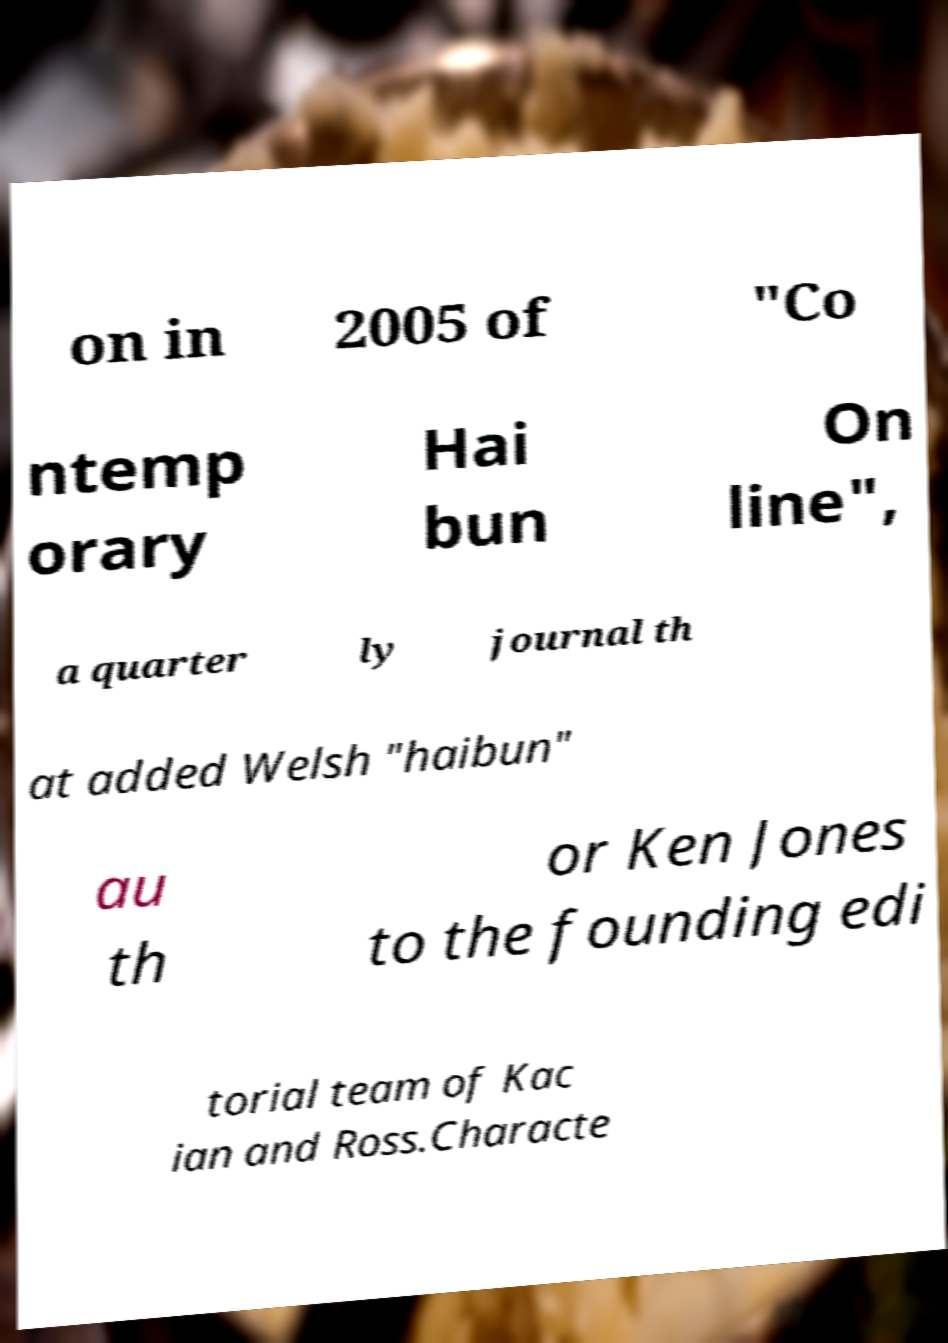There's text embedded in this image that I need extracted. Can you transcribe it verbatim? on in 2005 of "Co ntemp orary Hai bun On line", a quarter ly journal th at added Welsh "haibun" au th or Ken Jones to the founding edi torial team of Kac ian and Ross.Characte 